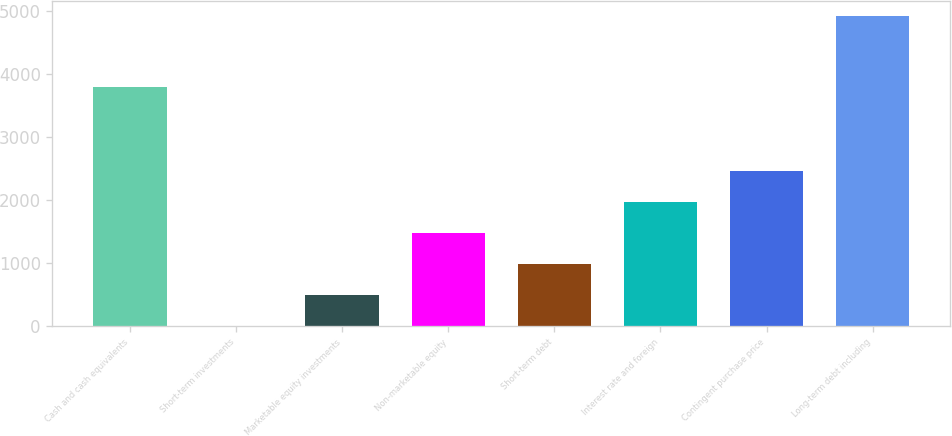<chart> <loc_0><loc_0><loc_500><loc_500><bar_chart><fcel>Cash and cash equivalents<fcel>Short-term investments<fcel>Marketable equity investments<fcel>Non-marketable equity<fcel>Short-term debt<fcel>Interest rate and foreign<fcel>Contingent purchase price<fcel>Long-term debt including<nl><fcel>3796<fcel>0.4<fcel>491.65<fcel>1474.15<fcel>982.9<fcel>1965.4<fcel>2456.65<fcel>4912.9<nl></chart> 